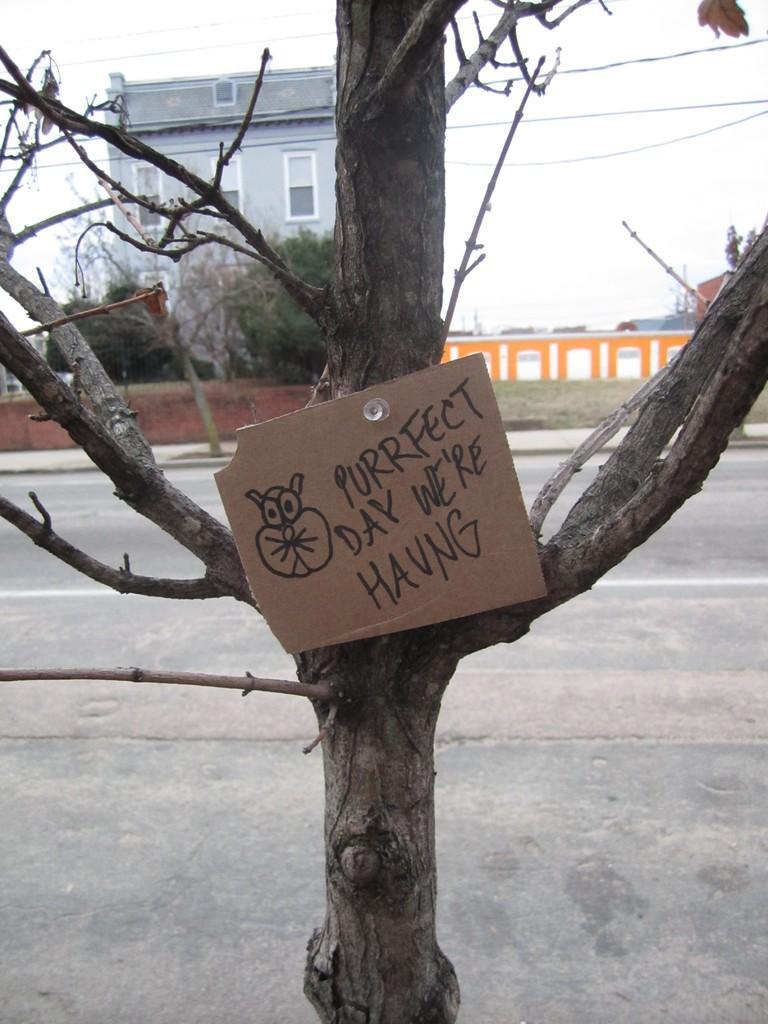Could you give a brief overview of what you see in this image? Here we can see a cardboard and there are trees. This is road and there is a wall. In the background we can see a building and this is sky. 